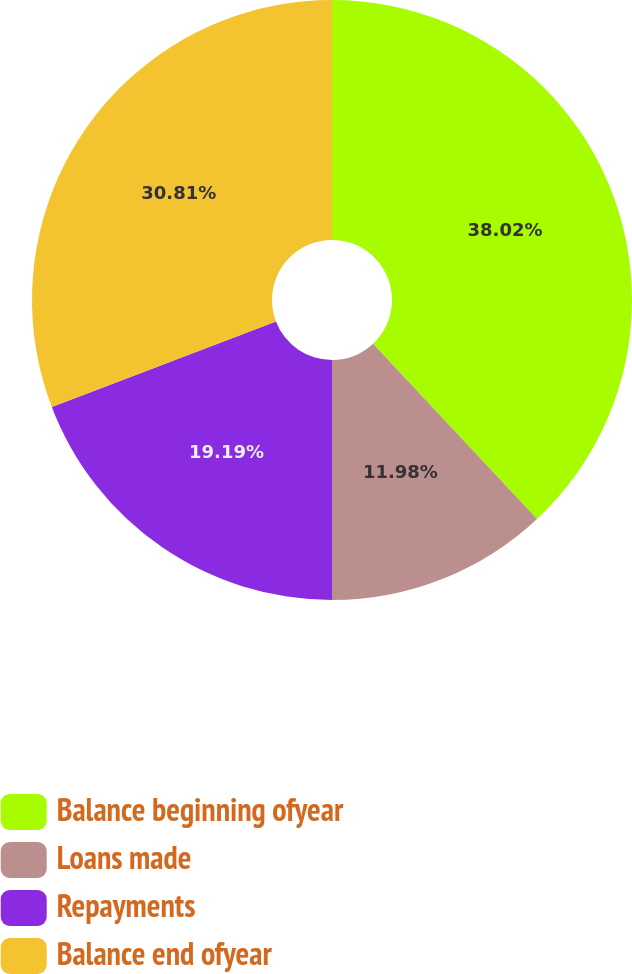Convert chart. <chart><loc_0><loc_0><loc_500><loc_500><pie_chart><fcel>Balance beginning ofyear<fcel>Loans made<fcel>Repayments<fcel>Balance end ofyear<nl><fcel>38.02%<fcel>11.98%<fcel>19.19%<fcel>30.81%<nl></chart> 